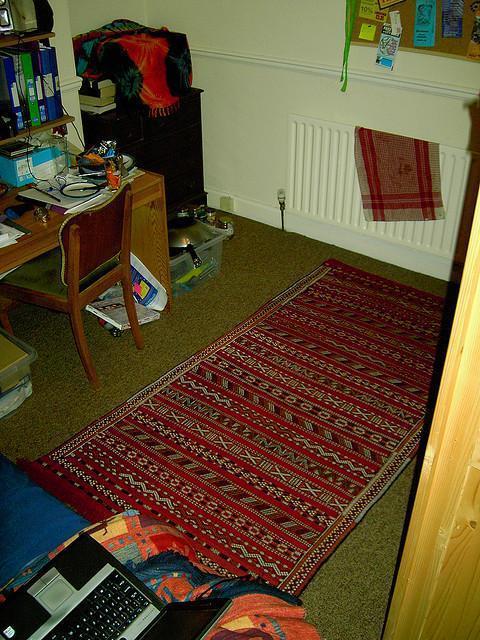How many women are in this picture?
Give a very brief answer. 0. 